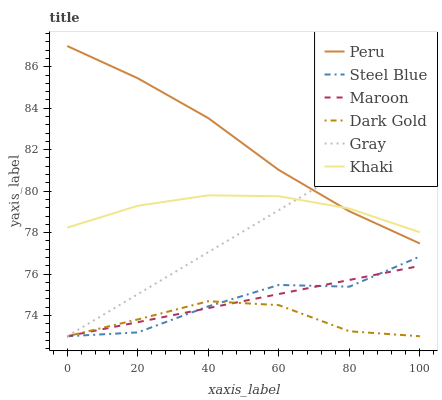Does Dark Gold have the minimum area under the curve?
Answer yes or no. Yes. Does Peru have the maximum area under the curve?
Answer yes or no. Yes. Does Khaki have the minimum area under the curve?
Answer yes or no. No. Does Khaki have the maximum area under the curve?
Answer yes or no. No. Is Maroon the smoothest?
Answer yes or no. Yes. Is Steel Blue the roughest?
Answer yes or no. Yes. Is Khaki the smoothest?
Answer yes or no. No. Is Khaki the roughest?
Answer yes or no. No. Does Khaki have the lowest value?
Answer yes or no. No. Does Peru have the highest value?
Answer yes or no. Yes. Does Khaki have the highest value?
Answer yes or no. No. Is Dark Gold less than Peru?
Answer yes or no. Yes. Is Peru greater than Dark Gold?
Answer yes or no. Yes. Does Maroon intersect Dark Gold?
Answer yes or no. Yes. Is Maroon less than Dark Gold?
Answer yes or no. No. Is Maroon greater than Dark Gold?
Answer yes or no. No. Does Dark Gold intersect Peru?
Answer yes or no. No. 